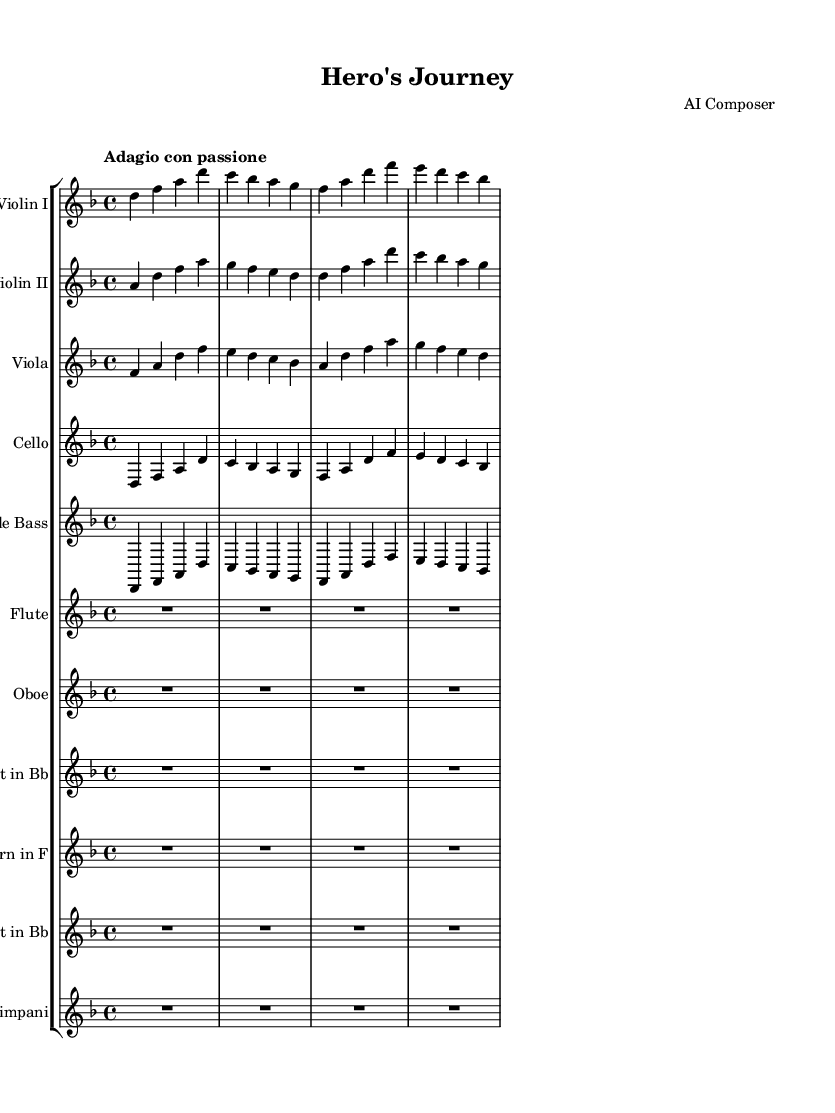What is the key signature of this music? The key signature is indicated at the beginning of the staff, showing two flats (B♭ and E♭). This means the piece is in D minor, as it has one flat in the relative major key (F major).
Answer: D minor What is the time signature of this piece? The time signature is represented right after the key signature and is indicated as 4/4, meaning there are four beats in each measure and the quarter note gets one beat.
Answer: 4/4 What is the tempo marking of this score? The tempo marking is written above the global section, showing "Adagio con passione," which indicates a slow tempo with passion.
Answer: Adagio con passione How many instruments are featured in this piece? By counting the individual staves in the score, there are eleven instruments shown, each represented by its own staff.
Answer: Eleven Which instruments play the same rhythm in the first few measures? By analyzing the first few measures, the Violin I, Cello, and Double Bass parts play the same rhythmic pattern, contributing to a unified sound.
Answer: Violin I, Cello, Double Bass How do the dynamics contribute to the expression in the piece? Dynamics are not indicated in the provided music, meaning performers are expected to interpret the emotional cues based on the tempo and phrasing. Without explicit markings, the expression is left more open to interpretation.
Answer: Open to interpretation What is the overall mood suggested by the orchestral arrangement? The orchestral arrangement, with strings providing a lyrical quality and woodwinds possibly adding color, suggests a dramatic and emotional struggle, typical for portraying literary heroes.
Answer: Dramatic and emotional 